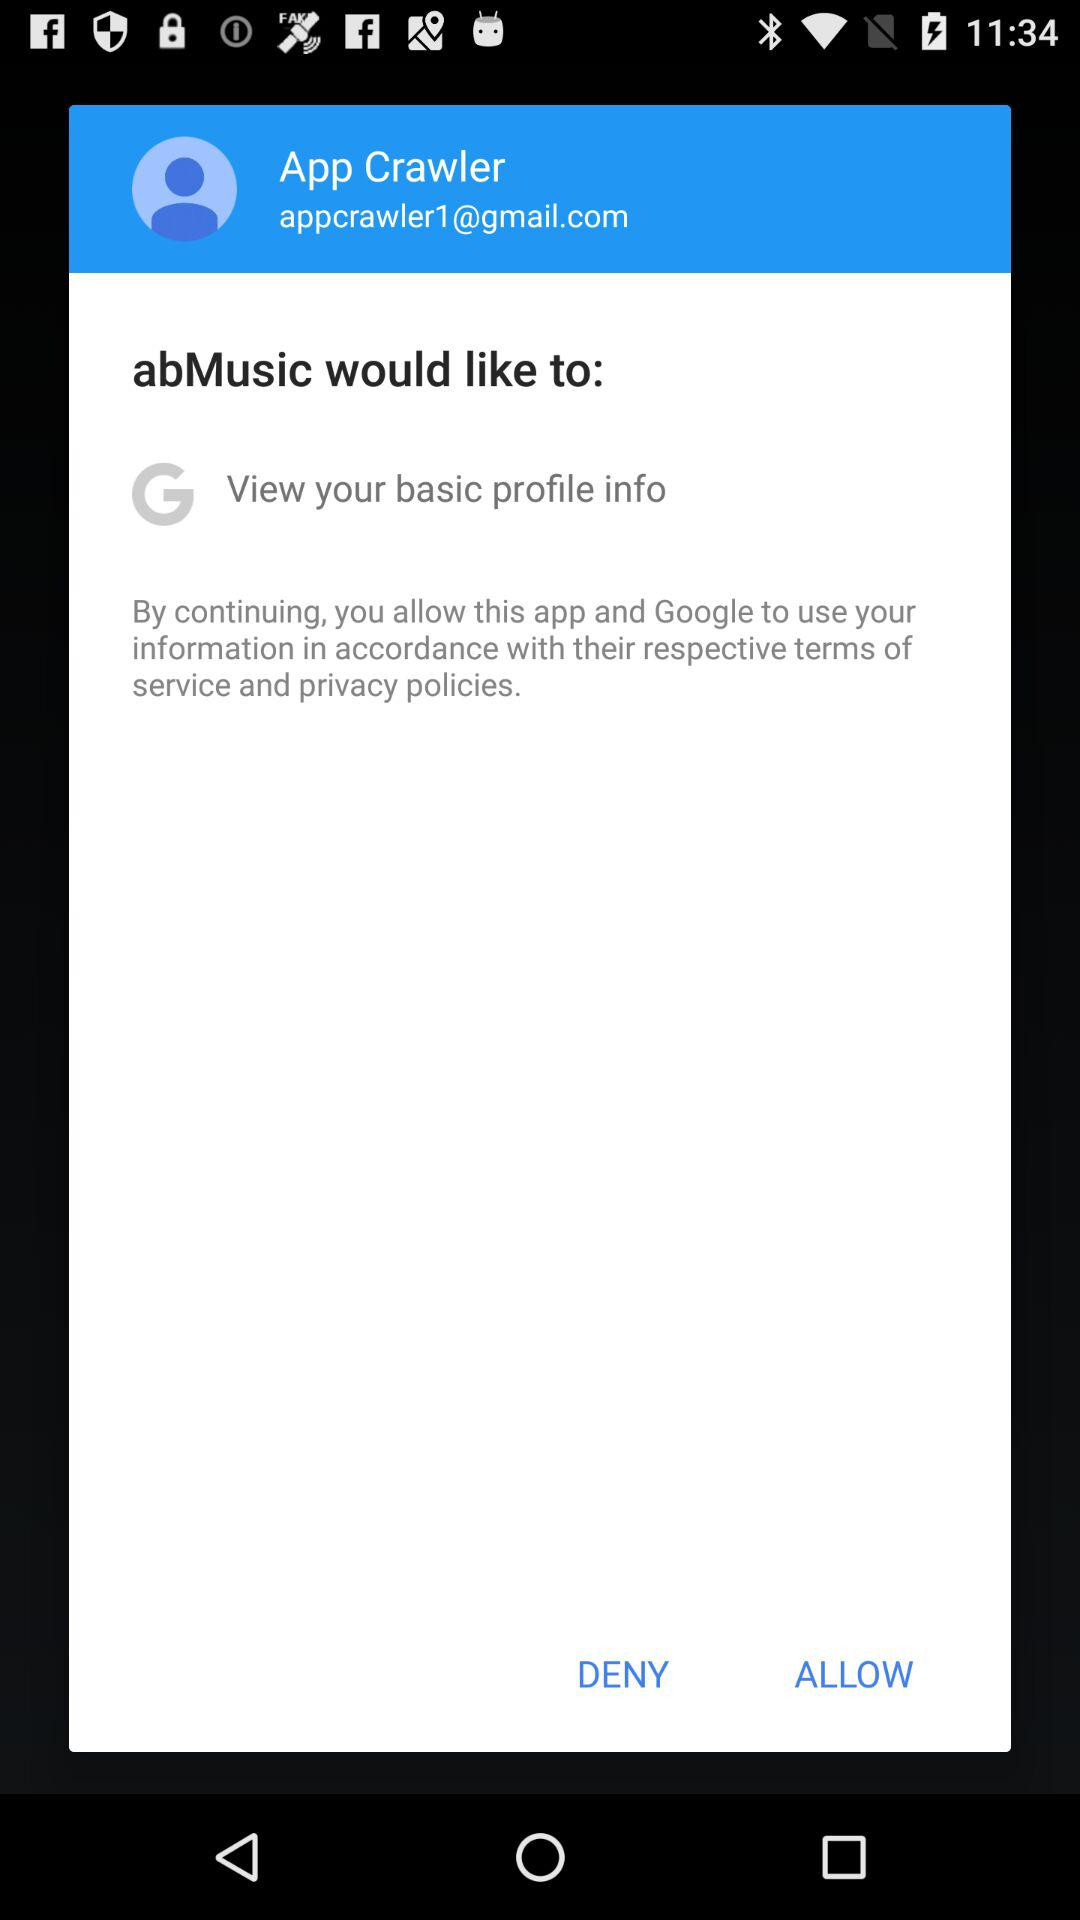What is the name of the user? The name of the user is App Crawler. 